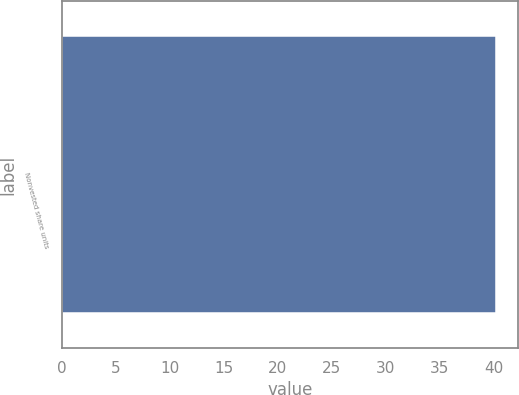Convert chart. <chart><loc_0><loc_0><loc_500><loc_500><bar_chart><fcel>Nonvested share units<nl><fcel>40.23<nl></chart> 